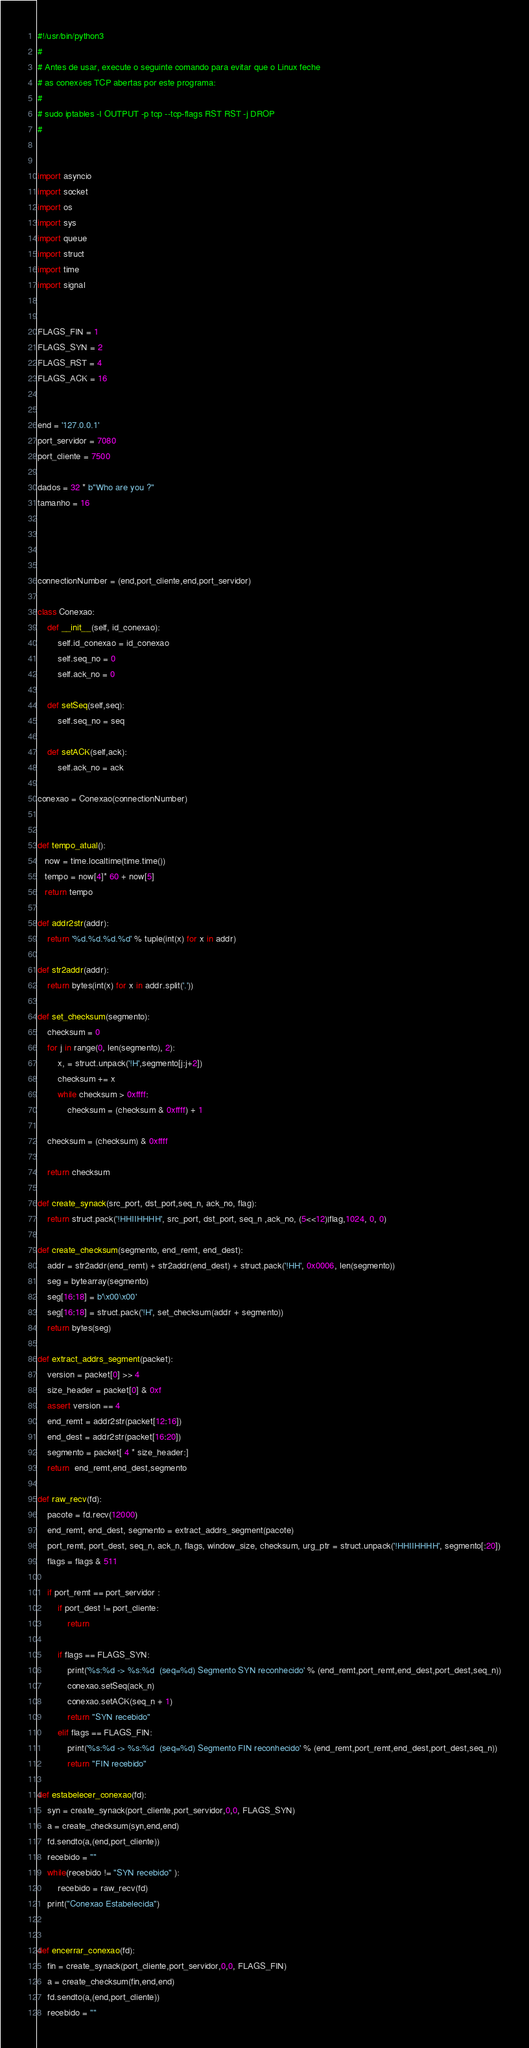<code> <loc_0><loc_0><loc_500><loc_500><_Python_>#!/usr/bin/python3
#
# Antes de usar, execute o seguinte comando para evitar que o Linux feche
# as conexões TCP abertas por este programa:
#
# sudo iptables -I OUTPUT -p tcp --tcp-flags RST RST -j DROP
# 


import asyncio
import socket
import os
import sys
import queue
import struct
import time
import signal


FLAGS_FIN = 1
FLAGS_SYN = 2
FLAGS_RST = 4
FLAGS_ACK = 16


end = '127.0.0.1'
port_servidor = 7080
port_cliente = 7500

dados = 32 * b"Who are you ?"
tamanho = 16




connectionNumber = (end,port_cliente,end,port_servidor)

class Conexao:
    def __init__(self, id_conexao):
        self.id_conexao = id_conexao
        self.seq_no = 0
        self.ack_no = 0
        
    def setSeq(self,seq):
        self.seq_no = seq
    
    def setACK(self,ack):
        self.ack_no = ack

conexao = Conexao(connectionNumber)


def tempo_atual():
   now = time.localtime(time.time())
   tempo = now[4]* 60 + now[5]
   return tempo

def addr2str(addr):
    return '%d.%d.%d.%d' % tuple(int(x) for x in addr)

def str2addr(addr):
    return bytes(int(x) for x in addr.split('.'))

def set_checksum(segmento):
    checksum = 0
    for j in range(0, len(segmento), 2):
        x, = struct.unpack('!H',segmento[j:j+2])
        checksum += x
        while checksum > 0xffff:
            checksum = (checksum & 0xffff) + 1

    checksum = (checksum) & 0xffff
    
    return checksum

def create_synack(src_port, dst_port,seq_n, ack_no, flag):
    return struct.pack('!HHIIHHHH', src_port, dst_port, seq_n ,ack_no, (5<<12)|flag,1024, 0, 0)

def create_checksum(segmento, end_remt, end_dest):
    addr = str2addr(end_remt) + str2addr(end_dest) + struct.pack('!HH', 0x0006, len(segmento))
    seg = bytearray(segmento)
    seg[16:18] = b'\x00\x00'
    seg[16:18] = struct.pack('!H', set_checksum(addr + segmento))
    return bytes(seg)

def extract_addrs_segment(packet):
    version = packet[0] >> 4
    size_header = packet[0] & 0xf
    assert version == 4
    end_remt = addr2str(packet[12:16])
    end_dest = addr2str(packet[16:20])
    segmento = packet[ 4 * size_header:]
    return  end_remt,end_dest,segmento

def raw_recv(fd):
    pacote = fd.recv(12000)
    end_remt, end_dest, segmento = extract_addrs_segment(pacote)
    port_remt, port_dest, seq_n, ack_n, flags, window_size, checksum, urg_ptr = struct.unpack('!HHIIHHHH', segmento[:20])
    flags = flags & 511
    
    if port_remt == port_servidor :
        if port_dest != port_cliente:
            return
        
        if flags == FLAGS_SYN:
            print('%s:%d -> %s:%d  (seq=%d) Segmento SYN reconhecido' % (end_remt,port_remt,end_dest,port_dest,seq_n))
            conexao.setSeq(ack_n)
            conexao.setACK(seq_n + 1)
            return "SYN recebido"
        elif flags == FLAGS_FIN:
            print('%s:%d -> %s:%d  (seq=%d) Segmento FIN reconhecido' % (end_remt,port_remt,end_dest,port_dest,seq_n))
            return "FIN recebido"
           
def estabelecer_conexao(fd):
    syn = create_synack(port_cliente,port_servidor,0,0, FLAGS_SYN)
    a = create_checksum(syn,end,end)
    fd.sendto(a,(end,port_cliente))
    recebido = ""
    while(recebido != "SYN recebido" ):
        recebido = raw_recv(fd)
    print("Conexao Estabelecida")
    
 
def encerrar_conexao(fd):
    fin = create_synack(port_cliente,port_servidor,0,0, FLAGS_FIN)
    a = create_checksum(fin,end,end)
    fd.sendto(a,(end,port_cliente))
    recebido = ""</code> 